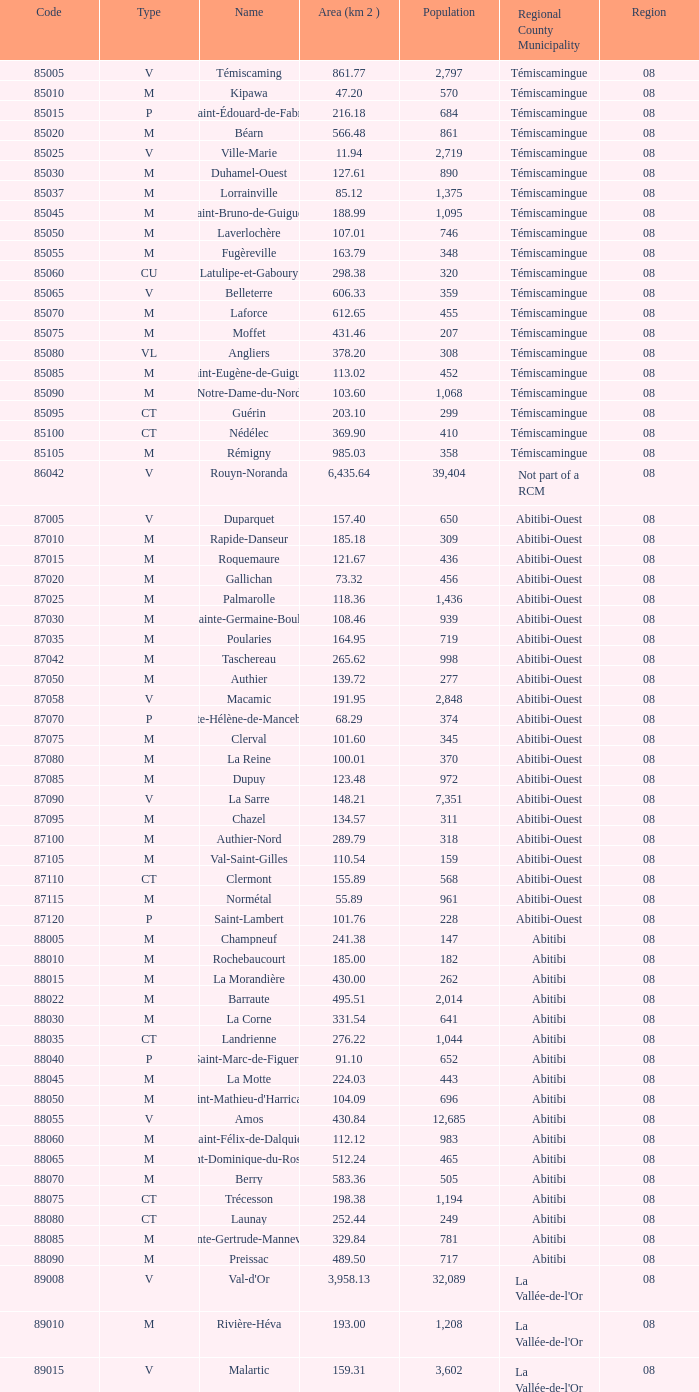For a population of 311, what is the area in square kilometers? 134.57. 